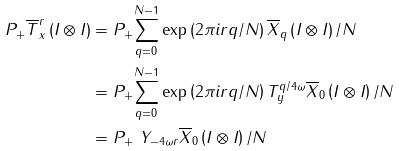Convert formula to latex. <formula><loc_0><loc_0><loc_500><loc_500>P _ { + } \overline { T } _ { x } ^ { r } \left ( I \otimes I \right ) & = P _ { + } \underset { q = 0 } { \sum ^ { N - 1 } } \exp \left ( 2 \pi i r q / N \right ) \overline { X } _ { q } \left ( I \otimes I \right ) / N \\ & = P _ { + } \underset { q = 0 } { \sum ^ { N - 1 } } \exp \left ( 2 \pi i r q / N \right ) T _ { y } ^ { q / 4 \omega } \overline { X } _ { 0 } \left ( I \otimes I \right ) / N \\ & = P _ { + } \text { } Y _ { - 4 \omega r } \overline { X } _ { 0 } \left ( I \otimes I \right ) / N</formula> 